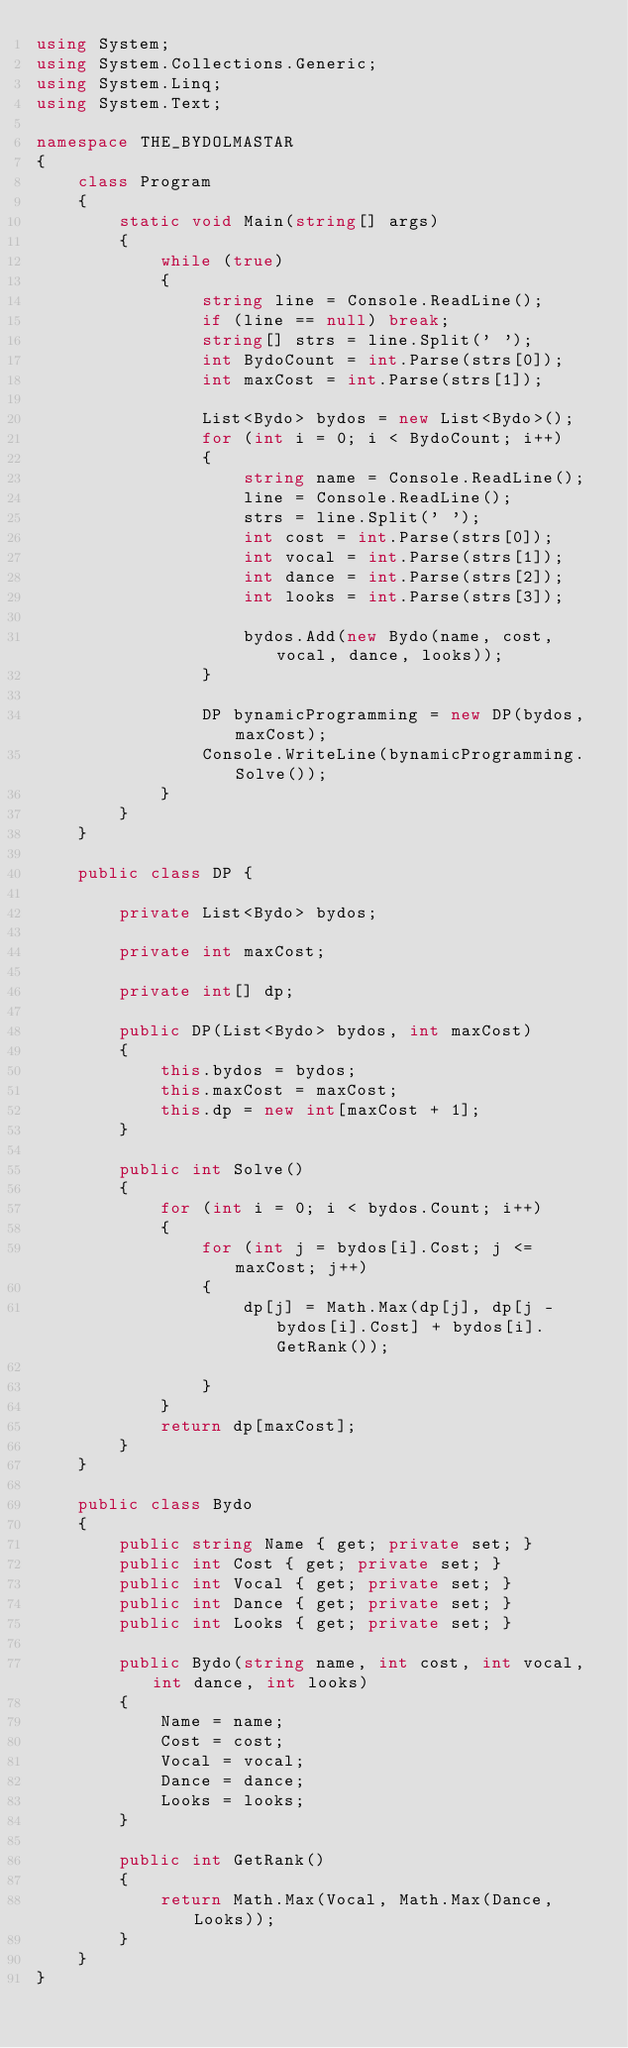<code> <loc_0><loc_0><loc_500><loc_500><_C#_>using System;
using System.Collections.Generic;
using System.Linq;
using System.Text;

namespace THE_BYDOLMASTAR
{
    class Program
    {
        static void Main(string[] args)
        {
            while (true)
            {
                string line = Console.ReadLine();
                if (line == null) break;
                string[] strs = line.Split(' ');
                int BydoCount = int.Parse(strs[0]);
                int maxCost = int.Parse(strs[1]);

                List<Bydo> bydos = new List<Bydo>();
                for (int i = 0; i < BydoCount; i++)
                {
                    string name = Console.ReadLine();
                    line = Console.ReadLine();
                    strs = line.Split(' ');
                    int cost = int.Parse(strs[0]);
                    int vocal = int.Parse(strs[1]);
                    int dance = int.Parse(strs[2]);
                    int looks = int.Parse(strs[3]);

                    bydos.Add(new Bydo(name, cost, vocal, dance, looks));
                }

                DP bynamicProgramming = new DP(bydos, maxCost);
                Console.WriteLine(bynamicProgramming.Solve());
            }
        }
    }

    public class DP {

        private List<Bydo> bydos;

        private int maxCost;

        private int[] dp;

        public DP(List<Bydo> bydos, int maxCost)
        {
            this.bydos = bydos;
            this.maxCost = maxCost;
            this.dp = new int[maxCost + 1];
        }

        public int Solve()
        {
            for (int i = 0; i < bydos.Count; i++)
            {
                for (int j = bydos[i].Cost; j <= maxCost; j++)
                {
                    dp[j] = Math.Max(dp[j], dp[j - bydos[i].Cost] + bydos[i].GetRank());
                    
                }
            }
            return dp[maxCost];
        }
    }

    public class Bydo
    {
        public string Name { get; private set; }
        public int Cost { get; private set; }
        public int Vocal { get; private set; }
        public int Dance { get; private set; }
        public int Looks { get; private set; }

        public Bydo(string name, int cost, int vocal, int dance, int looks)
        {
            Name = name;
            Cost = cost;
            Vocal = vocal;
            Dance = dance;
            Looks = looks;
        }

        public int GetRank()
        {
            return Math.Max(Vocal, Math.Max(Dance, Looks));
        }
    }
}</code> 